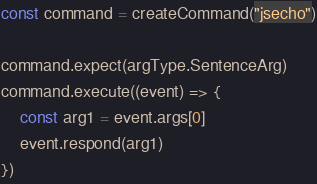<code> <loc_0><loc_0><loc_500><loc_500><_JavaScript_>const command = createCommand("jsecho")

command.expect(argType.SentenceArg)
command.execute((event) => {
    const arg1 = event.args[0]
    event.respond(arg1)
})</code> 